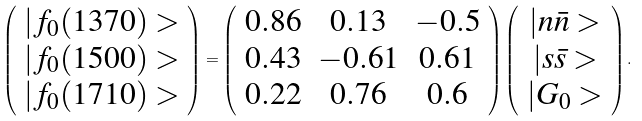<formula> <loc_0><loc_0><loc_500><loc_500>\left ( \begin{array} { c } | f _ { 0 } ( 1 3 7 0 ) > \\ | f _ { 0 } ( 1 5 0 0 ) > \\ | f _ { 0 } ( 1 7 1 0 ) > \end{array} \right ) = \left ( \begin{array} { c c c } 0 . 8 6 & 0 . 1 3 & - 0 . 5 \\ 0 . 4 3 & - 0 . 6 1 & 0 . 6 1 \\ 0 . 2 2 & 0 . 7 6 & 0 . 6 \end{array} \right ) \left ( \begin{array} { c } | n \bar { n } > \\ | s \bar { s } > \\ | G _ { 0 } > \end{array} \right ) .</formula> 